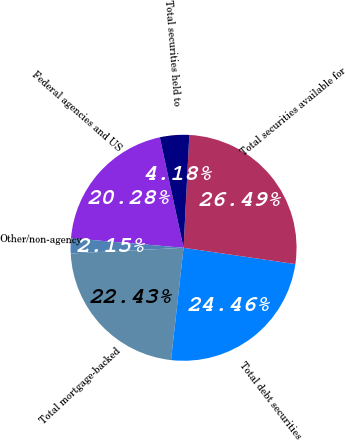Convert chart. <chart><loc_0><loc_0><loc_500><loc_500><pie_chart><fcel>Federal agencies and US<fcel>Other/non-agency<fcel>Total mortgage-backed<fcel>Total debt securities<fcel>Total securities available for<fcel>Total securities held to<nl><fcel>20.28%<fcel>2.15%<fcel>22.43%<fcel>24.46%<fcel>26.49%<fcel>4.18%<nl></chart> 